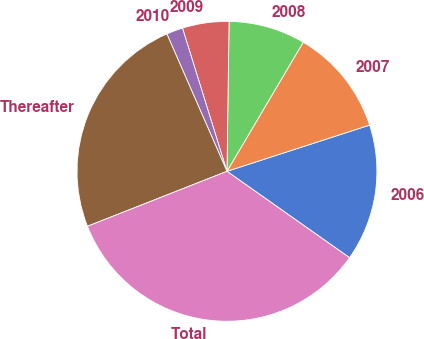<chart> <loc_0><loc_0><loc_500><loc_500><pie_chart><fcel>2006<fcel>2007<fcel>2008<fcel>2009<fcel>2010<fcel>Thereafter<fcel>Total<nl><fcel>14.76%<fcel>11.52%<fcel>8.27%<fcel>5.02%<fcel>1.77%<fcel>24.41%<fcel>34.26%<nl></chart> 